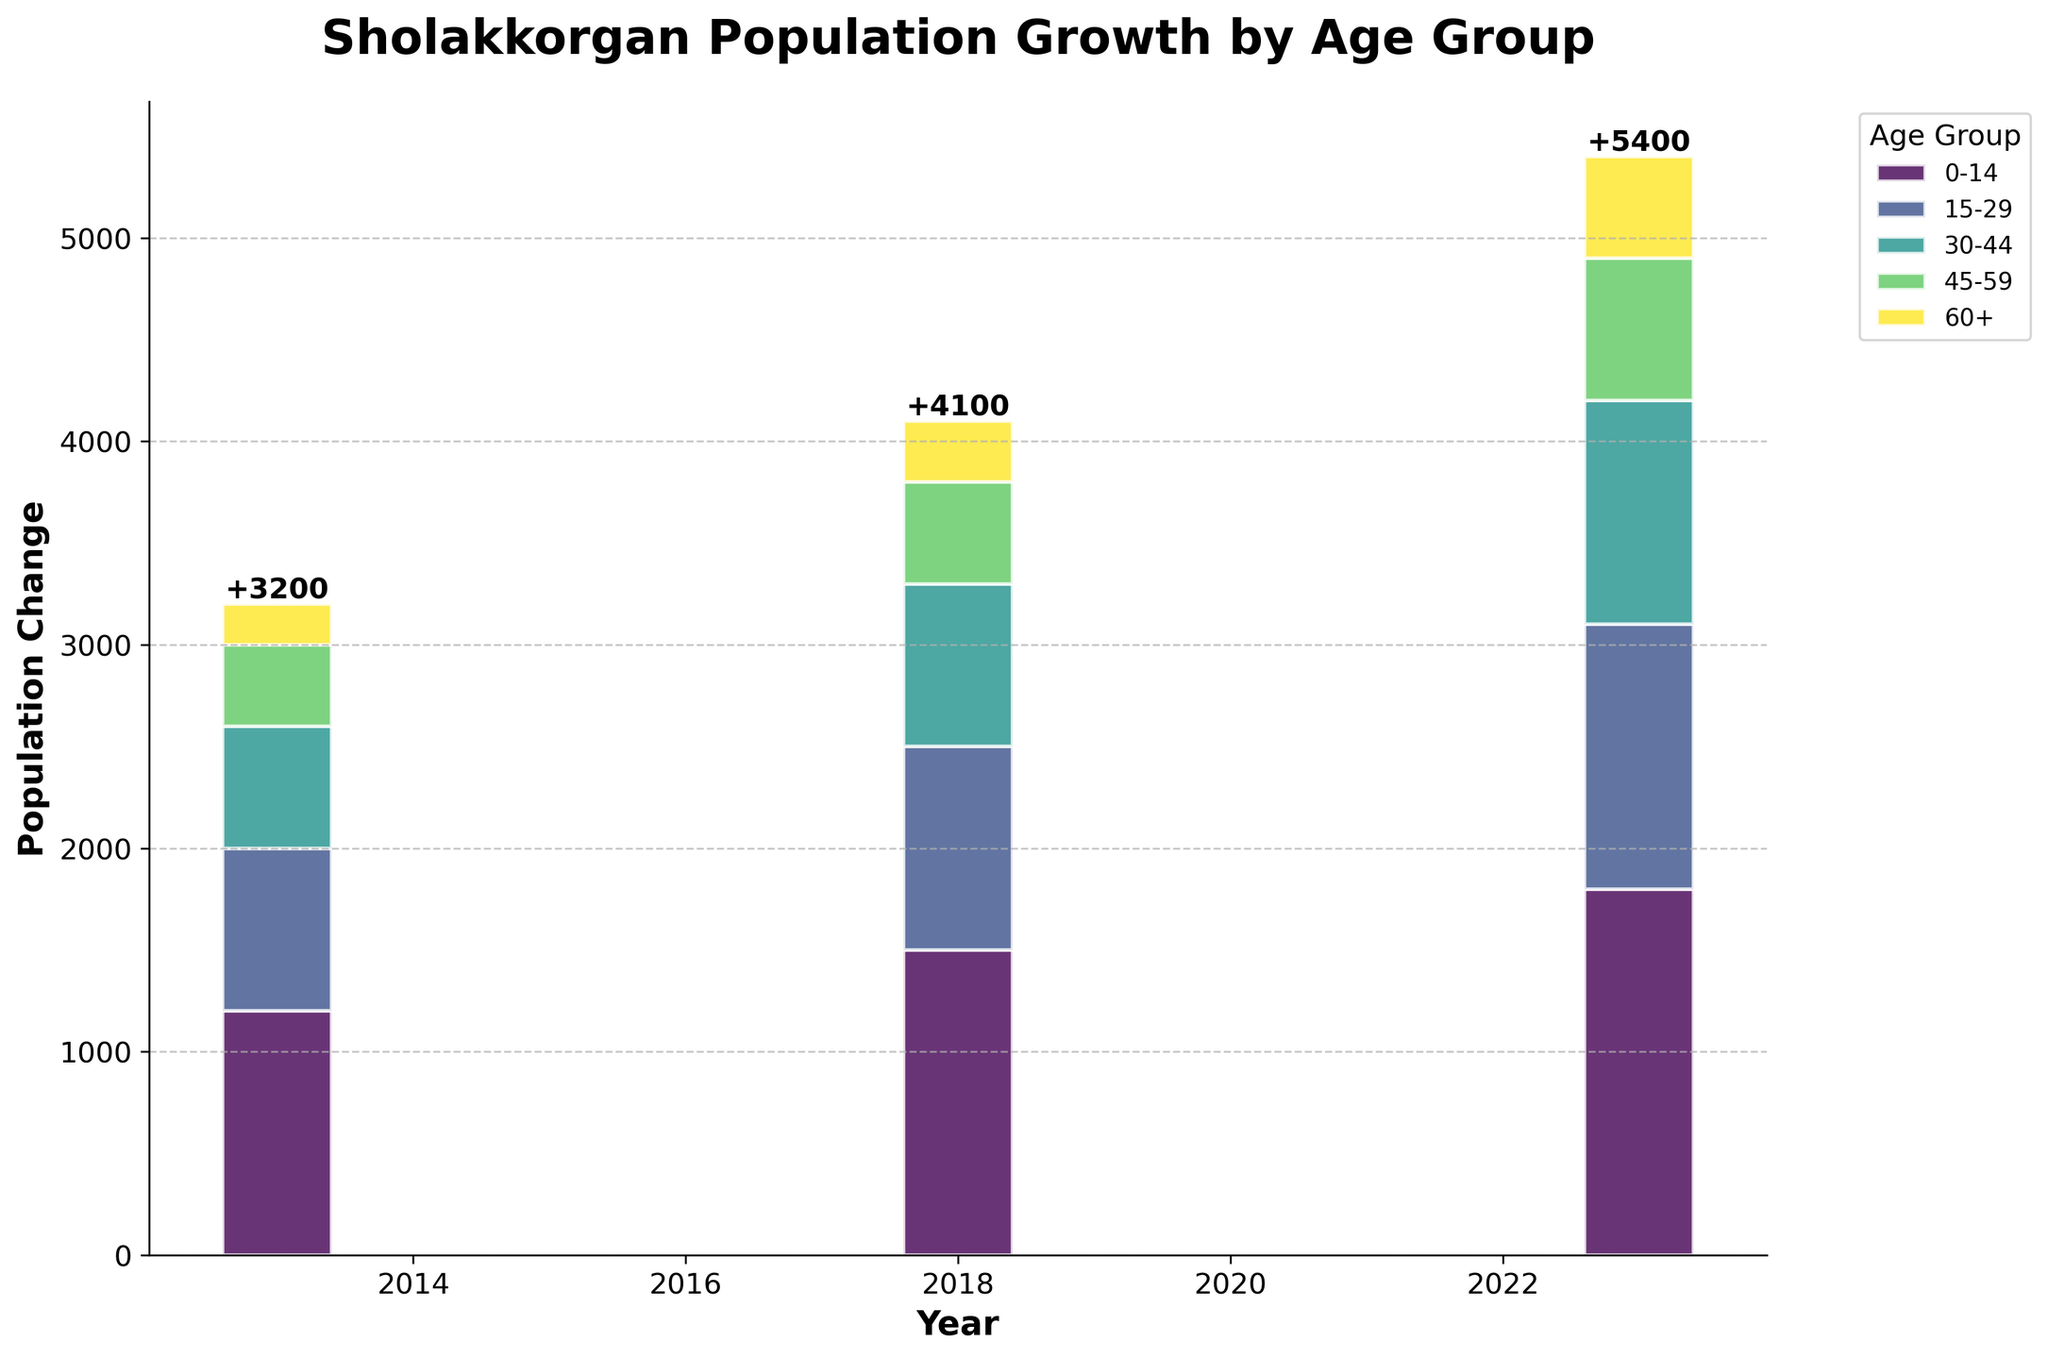What's the title of the figure? The title is located at the top of the figure, clearly indicating what the figure is about.
Answer: Sholakkorgan Population Growth by Age Group What are the age groups represented in the chart? The chart has a legend that lists the age groups. The age groups are 0-14, 15-29, 30-44, 45-59, and 60+.
Answer: 0-14, 15-29, 30-44, 45-59, 60+ How many years are displayed in the chart? The chart's x-axis contains the years, and there are three distinct years shown.
Answer: 3 Which age group had the most significant population change in 2023? The values for the year 2023 are displayed in separate segments of the bar. By looking at the height of each segment, the largest change is seen for the 0-14 age group.
Answer: 0-14 Compare the total population change from 2013 to 2023 for the age group 30-44. What’s the difference? First, identify the population change for the age group 30-44 in 2013 (600). Next, identify the same for 2023 (1100). Subtract the value for 2013 from the value for 2023: 1100 - 600 = 500.
Answer: 500 What is the total population change observed in 2018? Look at the text annotations above the 2018 bar summing up the segment heights indicating the population change for each age group. Total sum = 1500+1000+800+500+300 = 4100
Answer: 4100 How does the population change for the age group 45-59 in 2013 compare to that in 2023? Refer to the heights of the segments representing 45-59 for 2013 (400) and 2023 (700). 700 is greater than 400.
Answer: Higher in 2023 Which year saw the highest overall population change? Compare the total population change annotations above the bars for each year. 2023 has the highest value displayed.
Answer: 2023 How did the population of the age group 60+ change from 2013 to 2018? Look at the height of the segments for 2013 (200) and 2018 (300). Calculate the difference: 300 - 200 = 100.
Answer: Increased by 100 What logic can you infer regarding population trends across age groups over the decade? Observe the heights of each age group segment for all years. Most age groups see an increase, particularly 0-14 and 15-29. This may suggest growth in younger demographics.
Answer: Younger age groups are increasing 